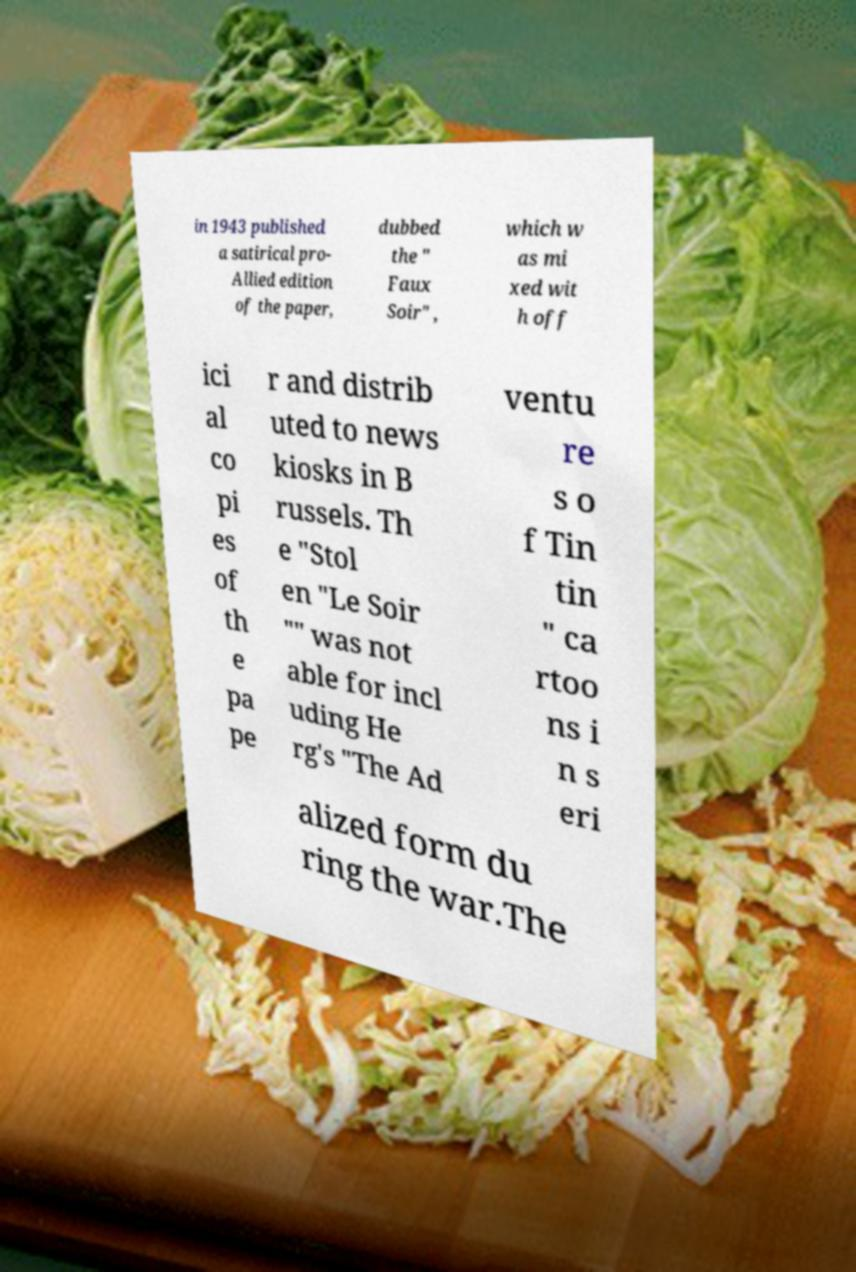Can you read and provide the text displayed in the image?This photo seems to have some interesting text. Can you extract and type it out for me? in 1943 published a satirical pro- Allied edition of the paper, dubbed the " Faux Soir" , which w as mi xed wit h off ici al co pi es of th e pa pe r and distrib uted to news kiosks in B russels. Th e "Stol en "Le Soir "" was not able for incl uding He rg's "The Ad ventu re s o f Tin tin " ca rtoo ns i n s eri alized form du ring the war.The 